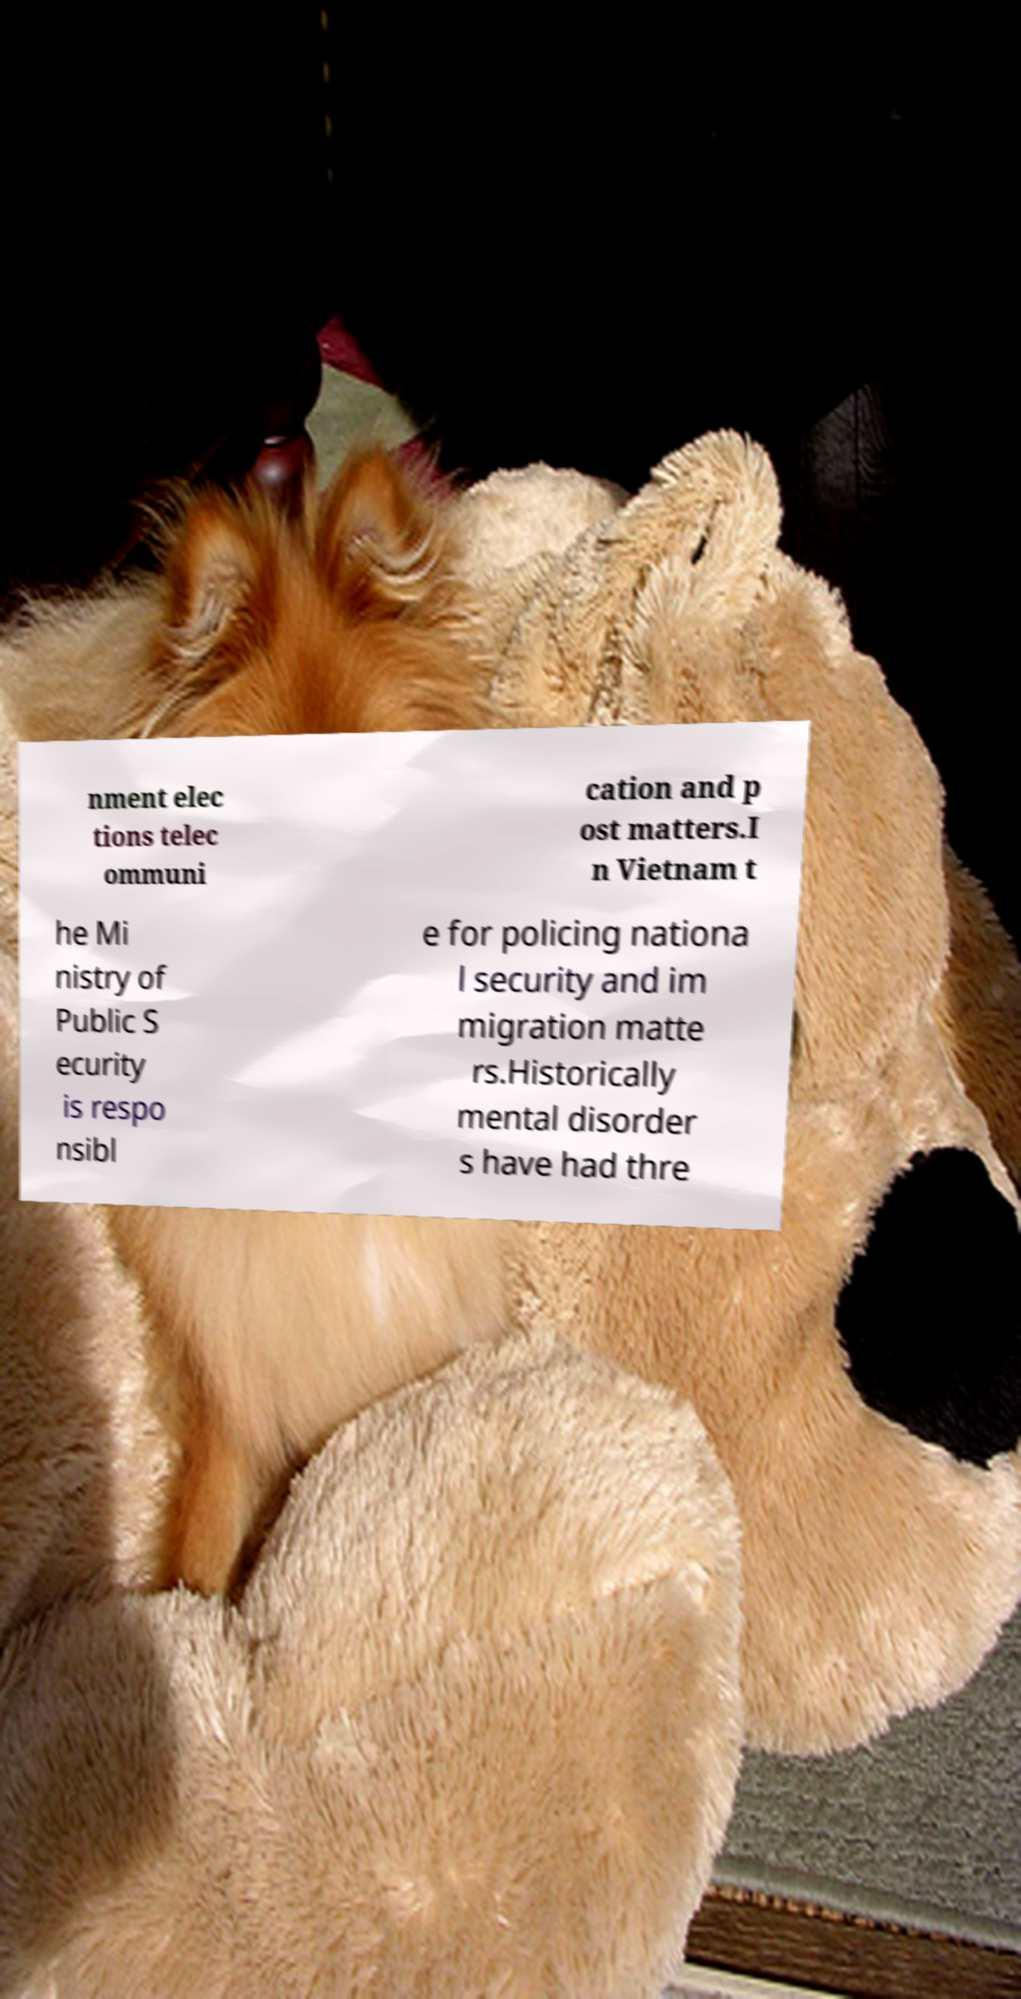Could you assist in decoding the text presented in this image and type it out clearly? nment elec tions telec ommuni cation and p ost matters.I n Vietnam t he Mi nistry of Public S ecurity is respo nsibl e for policing nationa l security and im migration matte rs.Historically mental disorder s have had thre 